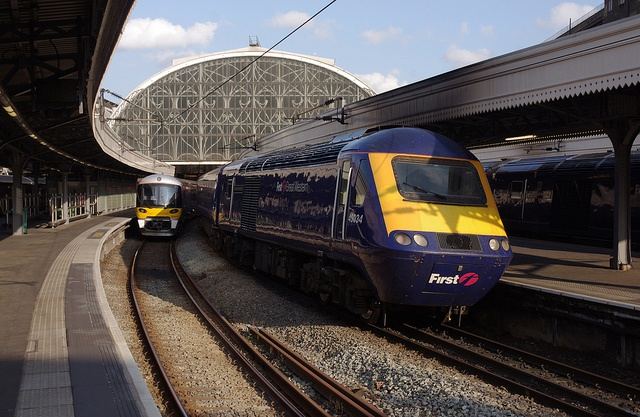Describe the objects in this image and their specific colors. I can see train in black, gray, navy, and gold tones, train in black, gray, and darkblue tones, and train in black, gray, darkgray, and lightgray tones in this image. 